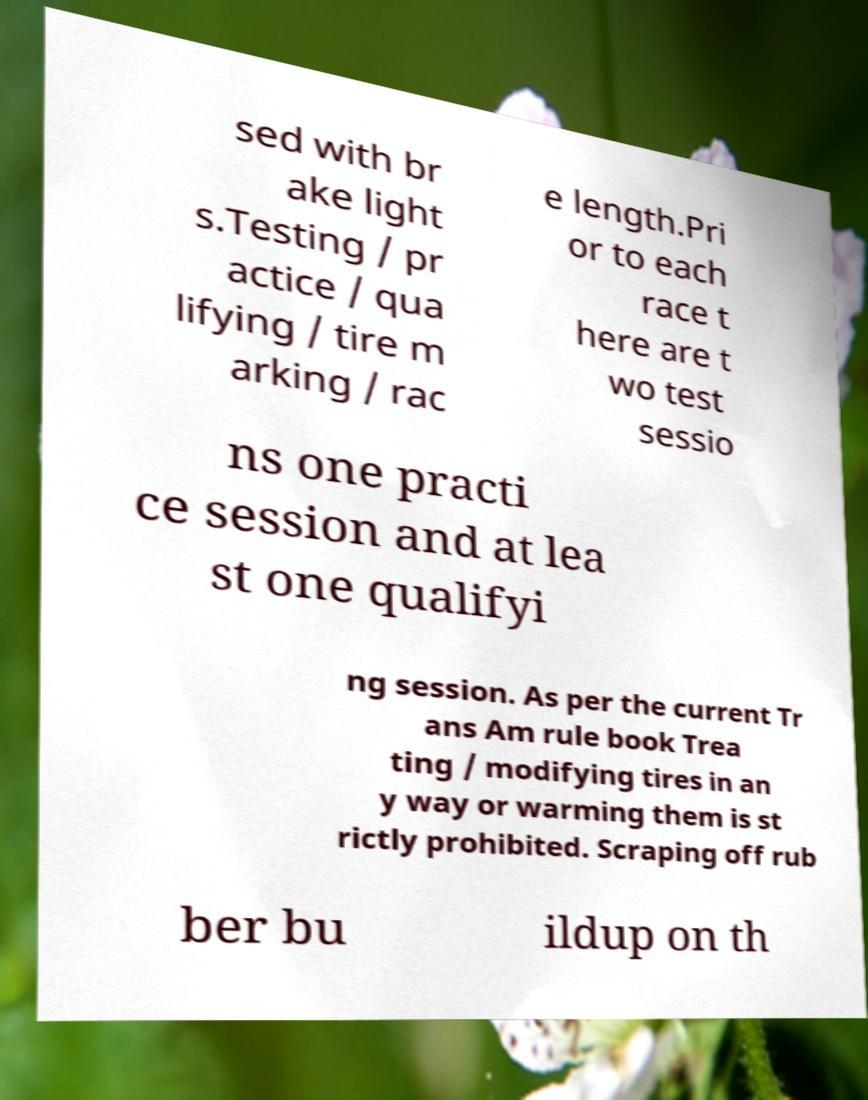Could you extract and type out the text from this image? sed with br ake light s.Testing / pr actice / qua lifying / tire m arking / rac e length.Pri or to each race t here are t wo test sessio ns one practi ce session and at lea st one qualifyi ng session. As per the current Tr ans Am rule book Trea ting / modifying tires in an y way or warming them is st rictly prohibited. Scraping off rub ber bu ildup on th 